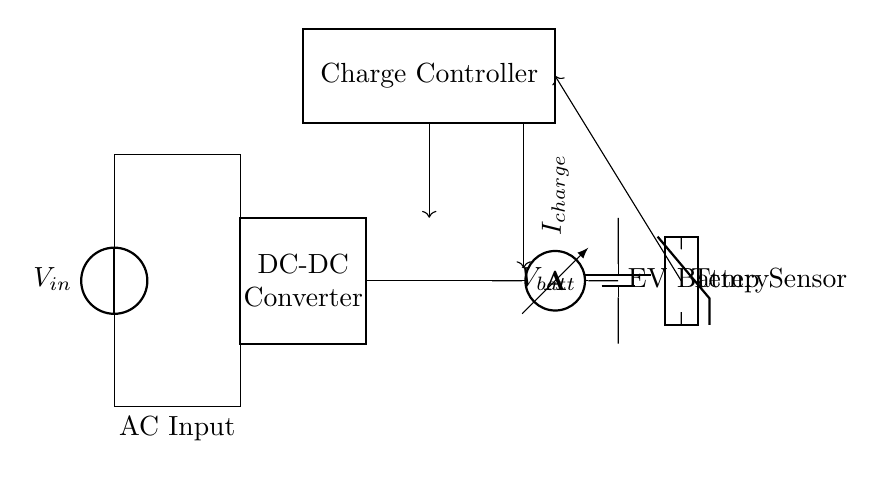What type of converter is shown in the circuit? The circuit includes a DC-DC converter, which is indicated by the rectangular box labeled "DC-DC Converter". This component is responsible for converting the input voltage to the appropriate level for charging the battery.
Answer: DC-DC converter What is the function of the charge controller? The charge controller is designed to regulate the voltage and current flowing to the battery, ensuring that it charges safely and efficiently. It is shown as a thick rectangle labeled "Charge Controller" in the circuit.
Answer: Regulate charging What current measurement device is present in the circuit? The circuit contains an ammeter, represented as a component with the label "I_charge", which measures the current being supplied to the battery during the charging process.
Answer: Ammeter What is connected to the temperature sensor? The temperature sensor is connected to the charge controller. The diagram shows an arrow indicating a control line from the temperature sensor to the charge controller, suggesting that temperature data influences charging decisions.
Answer: Charge controller What is the voltage at the battery terminals? The battery voltage, labeled as "V_batt", represents the potential at the terminals of the electric vehicle battery shown in the circuit. This value will depend on the battery specifications and state of charge.
Answer: V_batt What is the significance of the AC input in this circuit? The AC input serves as the power source for the circuit, providing the energy required to charge the electric vehicle battery after conversion through the DC-DC converter. It is labeled as "AC Input" at the bottom of the diagram.
Answer: Power source How does the charge controller respond to temperature changes? The charge controller likely adjusts the charging parameters based on the feedback from the temperature sensor. If the temperature exceeds safe levels, the controller can decrease the charging current or stop charging to protect the battery. This is inferred from the connection illustrated in the diagram.
Answer: Adjusts charging parameters 